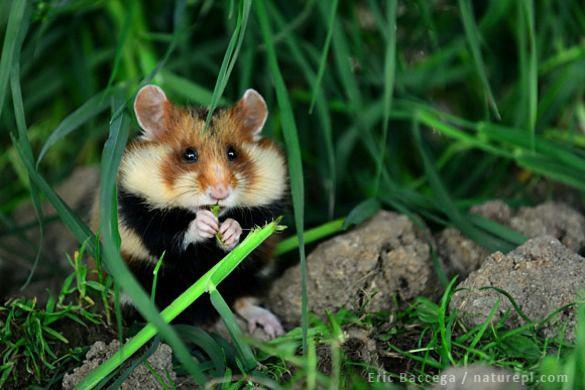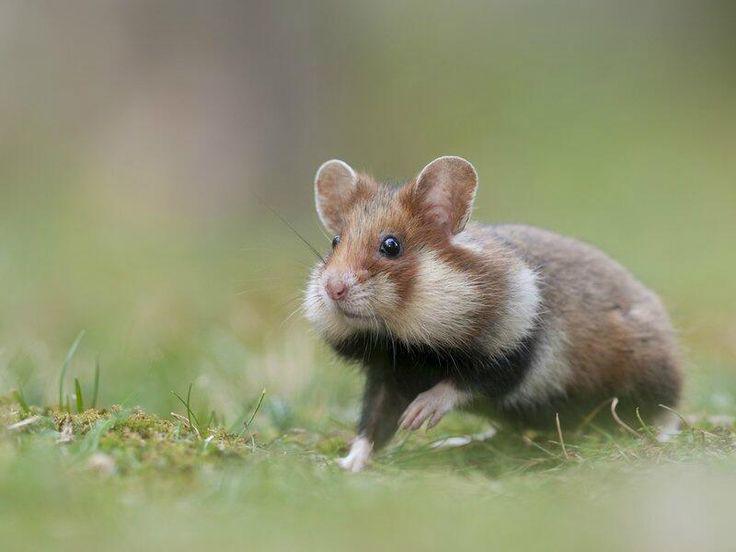The first image is the image on the left, the second image is the image on the right. Considering the images on both sides, is "the mouse on the left image is eating something" valid? Answer yes or no. Yes. 